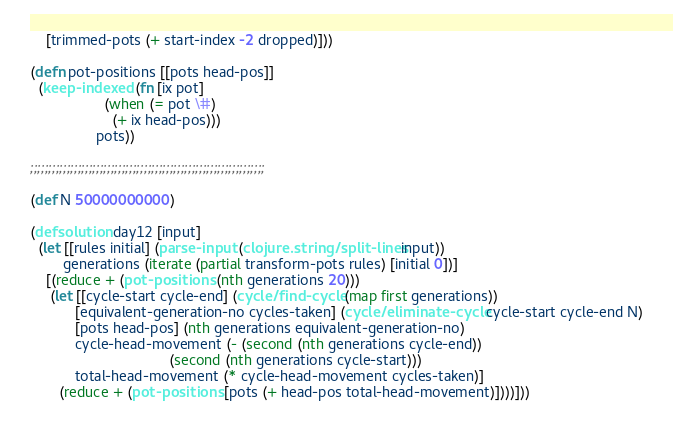<code> <loc_0><loc_0><loc_500><loc_500><_Clojure_>    [trimmed-pots (+ start-index -2 dropped)]))

(defn pot-positions [[pots head-pos]]
  (keep-indexed (fn [ix pot]
                  (when (= pot \#)
                    (+ ix head-pos)))
                pots))

;;;;;;;;;;;;;;;;;;;;;;;;;;;;;;;;;;;;;;;;;;;;;;;;;;;;;;;;;;;;;;;;

(def N 50000000000)

(defsolution day12 [input]
  (let [[rules initial] (parse-input (clojure.string/split-lines input))
        generations (iterate (partial transform-pots rules) [initial 0])]
    [(reduce + (pot-positions (nth generations 20)))
     (let [[cycle-start cycle-end] (cycle/find-cycle (map first generations))
           [equivalent-generation-no cycles-taken] (cycle/eliminate-cycle cycle-start cycle-end N)
           [pots head-pos] (nth generations equivalent-generation-no)
           cycle-head-movement (- (second (nth generations cycle-end))
                                  (second (nth generations cycle-start)))
           total-head-movement (* cycle-head-movement cycles-taken)]
       (reduce + (pot-positions [pots (+ head-pos total-head-movement)])))]))
</code> 